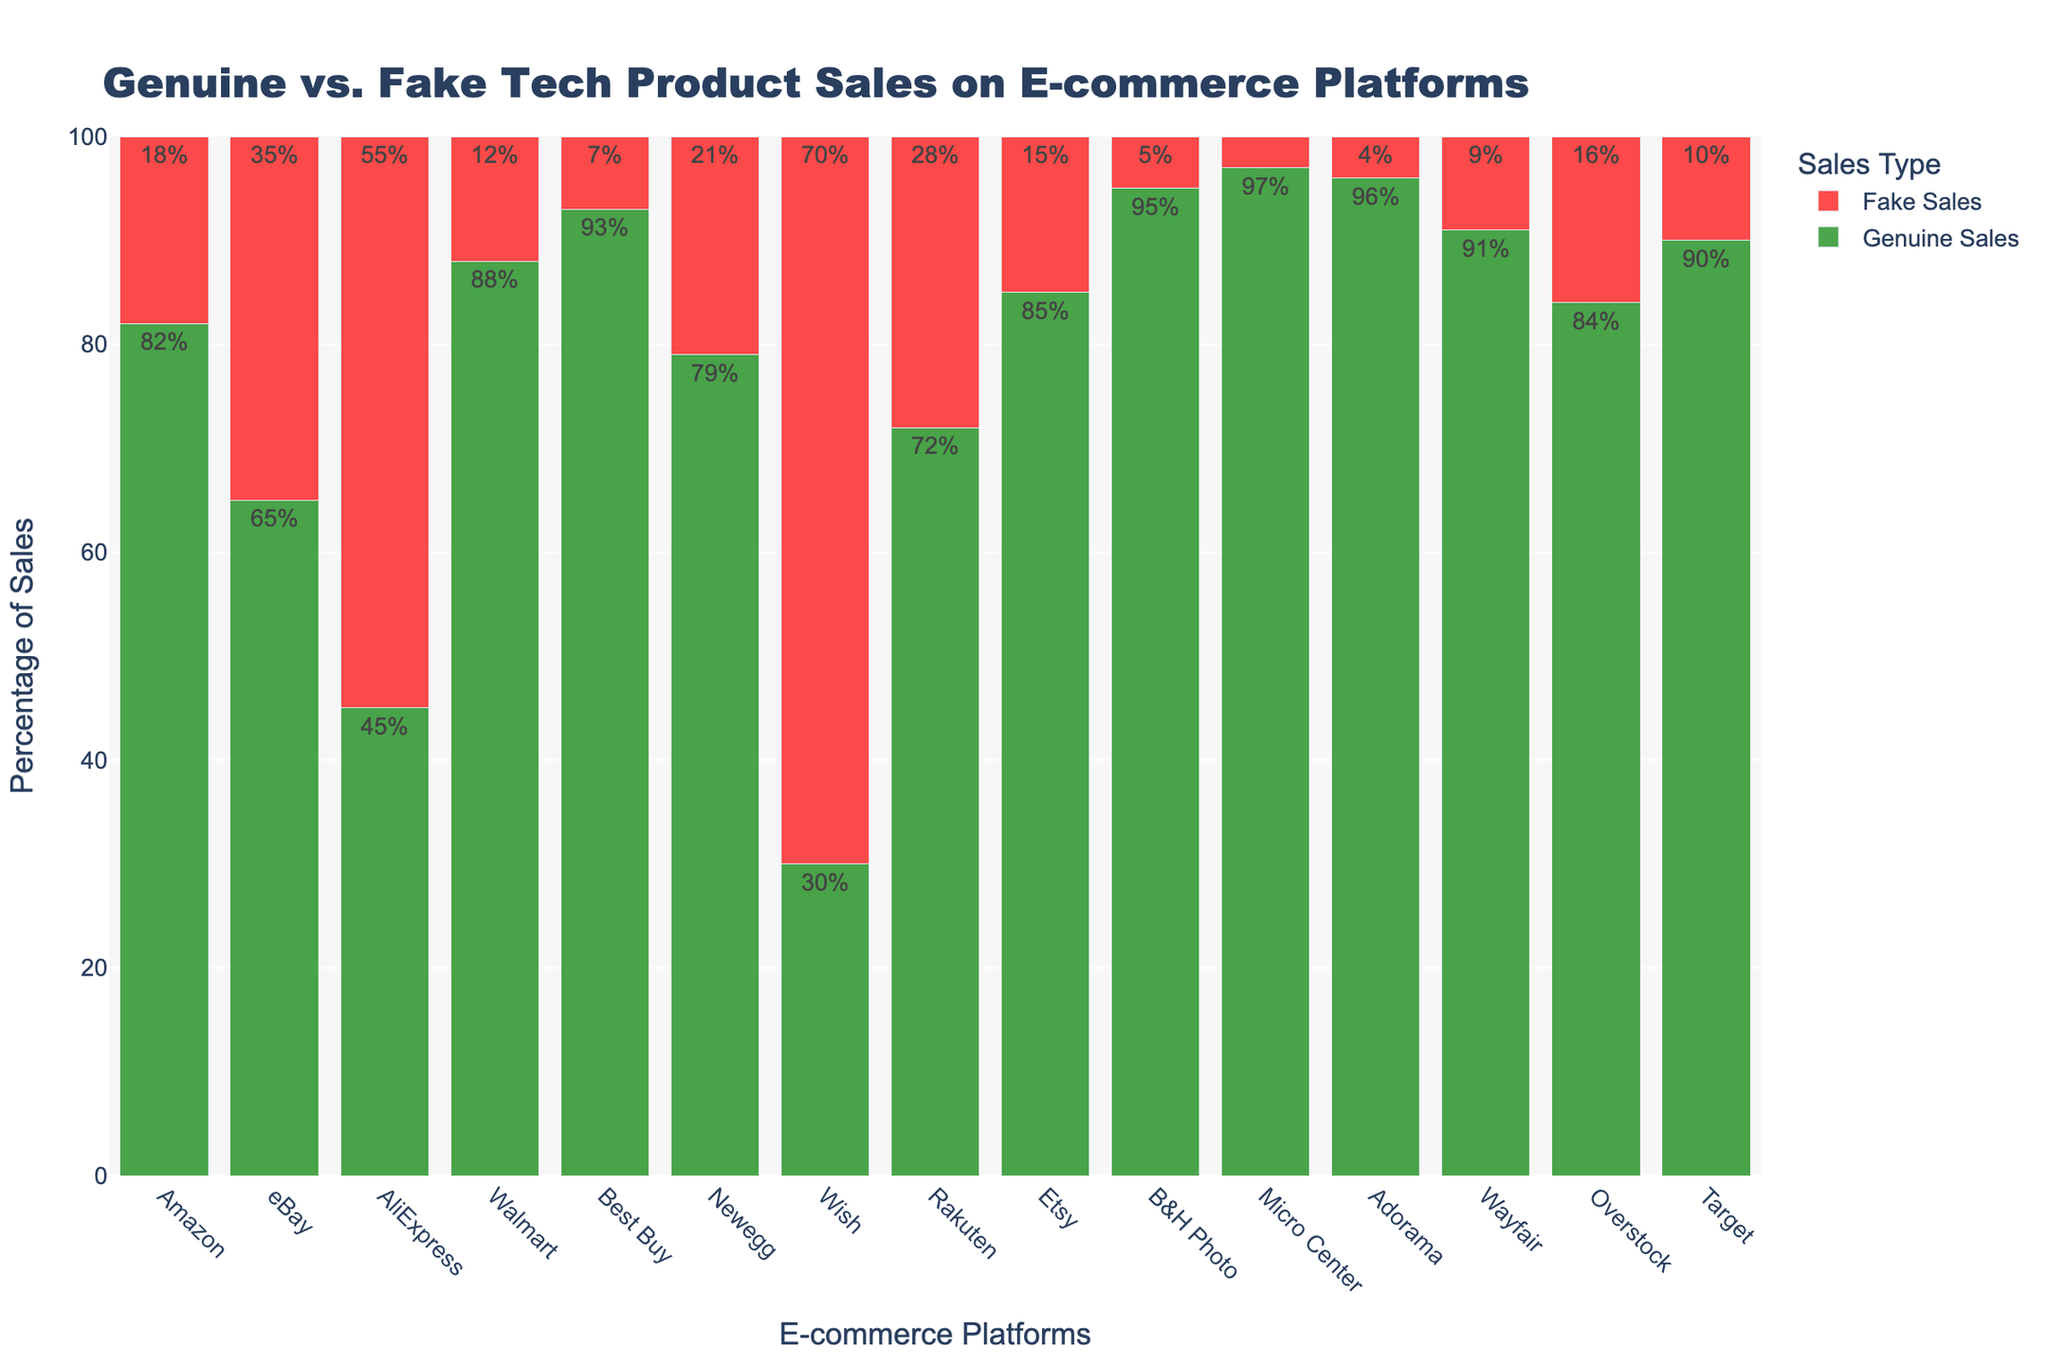Which e-commerce platform has the highest percentage of genuine tech product sales? The highest bar in the 'Genuine Sales' category represents Micro Center with 97%.
Answer: Micro Center Which e-commerce platform has the highest percentage of fake tech product sales? The highest bar in the 'Fake Sales' category represents Wish with 70%.
Answer: Wish Compare the genuine tech product sales percentages of Amazon and eBay. Which one is higher and by how much? Amazon's bar for 'Genuine Sales' is 82%, and eBay's is 65%. The difference is 82% - 65% = 17%.
Answer: Amazon by 17% What is the total percentage of genuine tech product sales for Amazon, eBay, and AliExpress combined? Sum the 'Genuine Sales' percentages for Amazon (82%), eBay (65%), and AliExpress (45%). 82% + 65% + 45% = 192%.
Answer: 192% Which two platforms have the most similar percentages of genuine sales, and what are those percentages? Looking at the 'Genuine Sales' bars, Etsy at 85% and Amazon at 82% are the closest in percentage. The difference is
Answer: Etsy (85%) and Amazon (82%) How much lower is the percentage of fake sales on Best Buy compared to Wish? Best Buy's 'Fake Sales' percentage is 7%, and Wish's 'Fake Sales' percentage is 70%. The difference is 70% - 7% = 63%.
Answer: 63% lower What is the difference in the total percentage of genuine and fake tech product sales for Newegg? Newegg's 'Genuine Sales' percentage is 79% and 'Fake Sales' percentage is 21%. The difference is 79% - 21% = 58%.
Answer: 58% On which platform is the visualization of genuine tech product sales percentage given in green and the highest on that platform? The highest green bar is for Micro Center with a 'Genuine Sales' percentage of 97%.
Answer: Micro Center, 97% What is the average percentage of fake tech product sales across Rakuten, Etsy, and B&H Photo? Sum the 'Fake Sales' percentages for Rakuten (28%), Etsy (15%), and B&H Photo (5%). The total is 28% + 15% + 5% = 48%. The average is 48% / 3 = 16%.
Answer: 16% Which platform has a higher percentage of genuine tech product sales, Rakuten or Overstock, and by how much? Rakuten's 'Genuine Sales' percentage is 72%, and Overstock's is 84%. The difference is 84% - 72% = 12%.
Answer: Overstock by 12% 